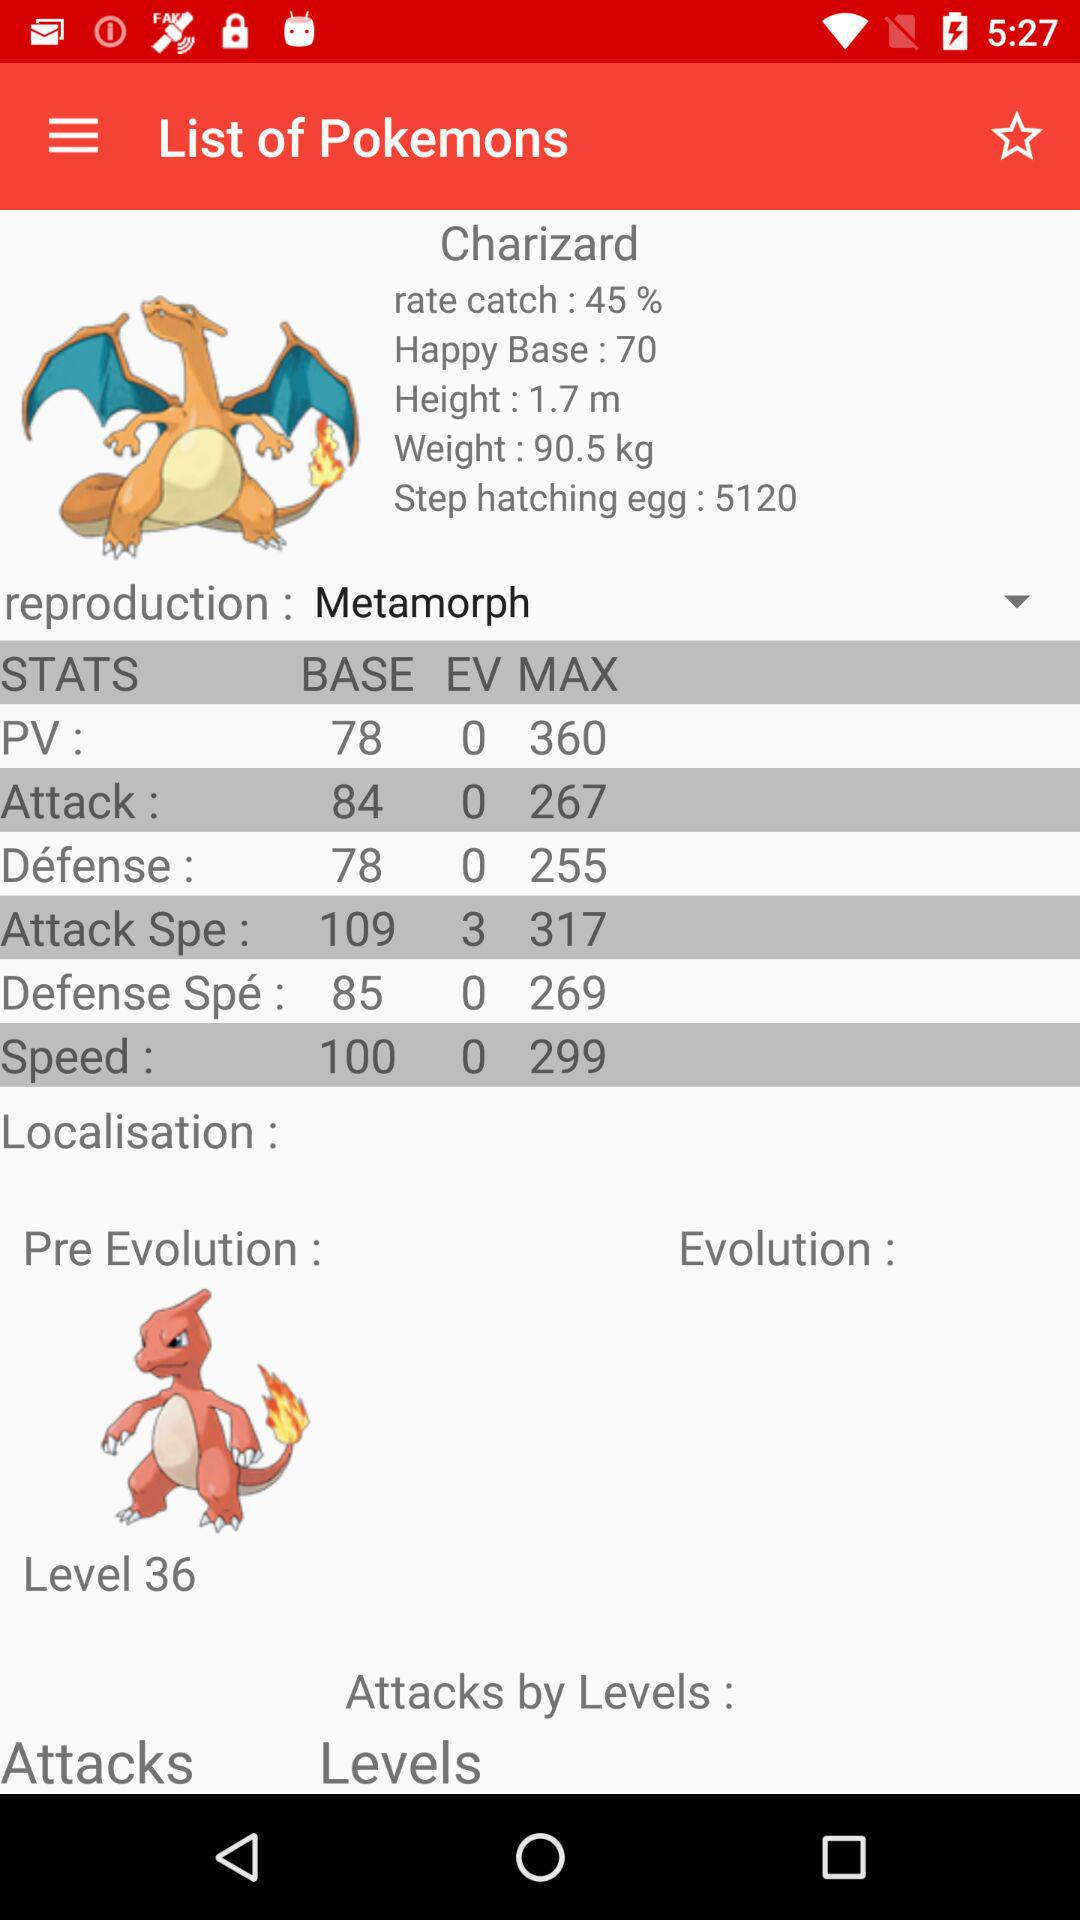What is the base speed? The base speed is 100. 